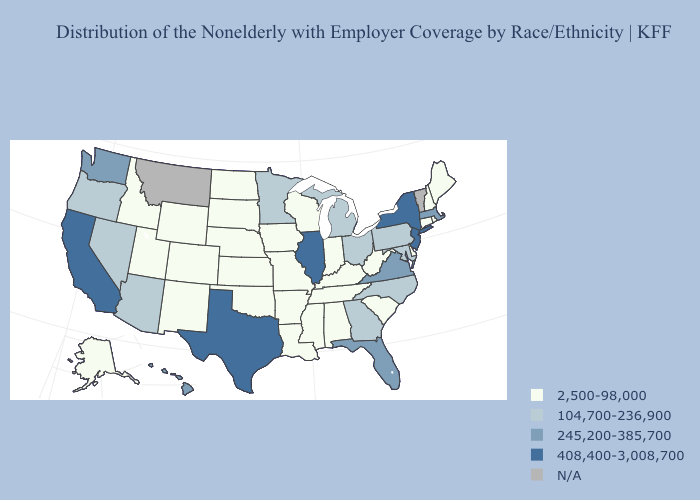Among the states that border Utah , which have the highest value?
Give a very brief answer. Arizona, Nevada. Does the map have missing data?
Short answer required. Yes. Among the states that border Maryland , which have the lowest value?
Concise answer only. Delaware, West Virginia. Among the states that border New Mexico , does Texas have the highest value?
Quick response, please. Yes. Name the states that have a value in the range 408,400-3,008,700?
Give a very brief answer. California, Illinois, New Jersey, New York, Texas. What is the lowest value in the South?
Short answer required. 2,500-98,000. Name the states that have a value in the range 245,200-385,700?
Short answer required. Florida, Hawaii, Massachusetts, Virginia, Washington. Name the states that have a value in the range N/A?
Be succinct. Montana, Vermont. Does Illinois have the highest value in the USA?
Write a very short answer. Yes. What is the highest value in the Northeast ?
Quick response, please. 408,400-3,008,700. Name the states that have a value in the range 104,700-236,900?
Keep it brief. Arizona, Georgia, Maryland, Michigan, Minnesota, Nevada, North Carolina, Ohio, Oregon, Pennsylvania. Does Nebraska have the lowest value in the MidWest?
Write a very short answer. Yes. 